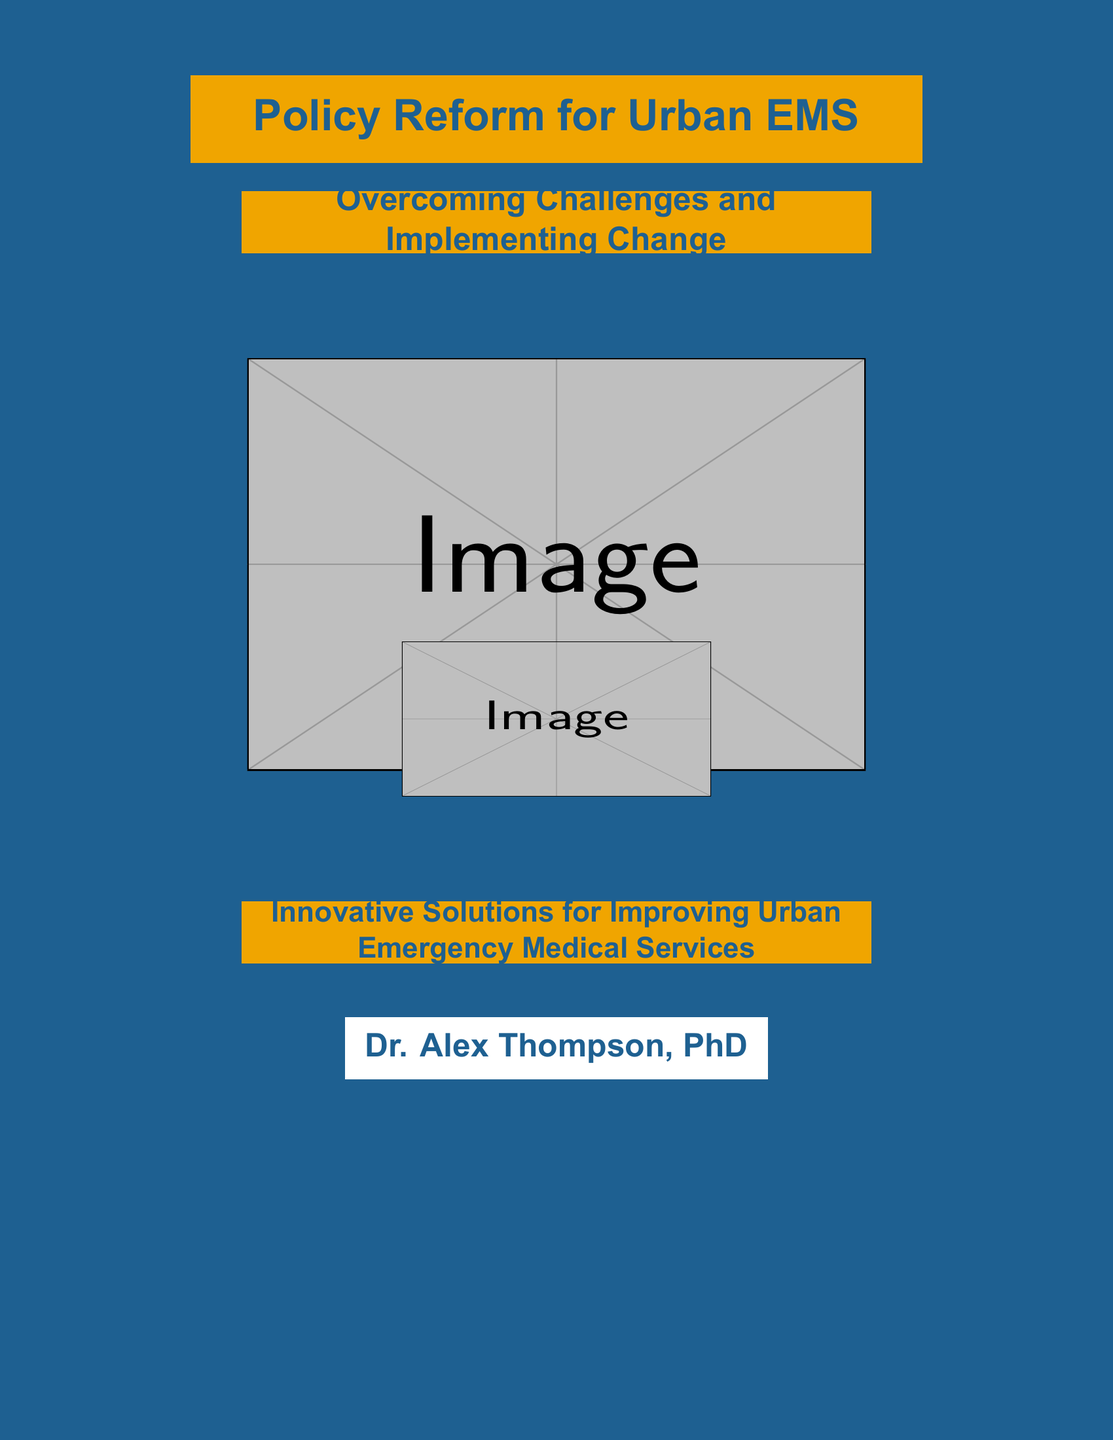What is the main title of the document? The main title is prominently displayed at the top and is "Policy Reform for Urban EMS."
Answer: Policy Reform for Urban EMS Who is the author of the document? The author's name is indicated at the bottom center of the cover as the person responsible for the content.
Answer: Dr. Alex Thompson, PhD What is the subtitle of the document? The subtitle provides insights into the focus of the content and is displayed below the main title.
Answer: Overcoming Challenges and Implementing Change What is the color of the background? The background color can be seen behind all elements of the cover.
Answer: Dark blue What is the graphic image displayed on the cover? The image relates to the context of the document and is located in the central part of the cover.
Answer: Skyline and ambulance What is the focus of the innovative solutions stated in the document? The phrase emphasizing the focus on improvement is found near the bottom of the cover.
Answer: Improving Urban Emergency Medical Services How many main colors are prominently featured on the cover? The colors used for text and background can be counted from the overall design of the cover.
Answer: Two What is the size of the main title font? The font size is specified for how prominently the title is presented on the cover.
Answer: 24 What type of document is this? The overall structure and presentation indicate the nature of this document type.
Answer: Book cover 